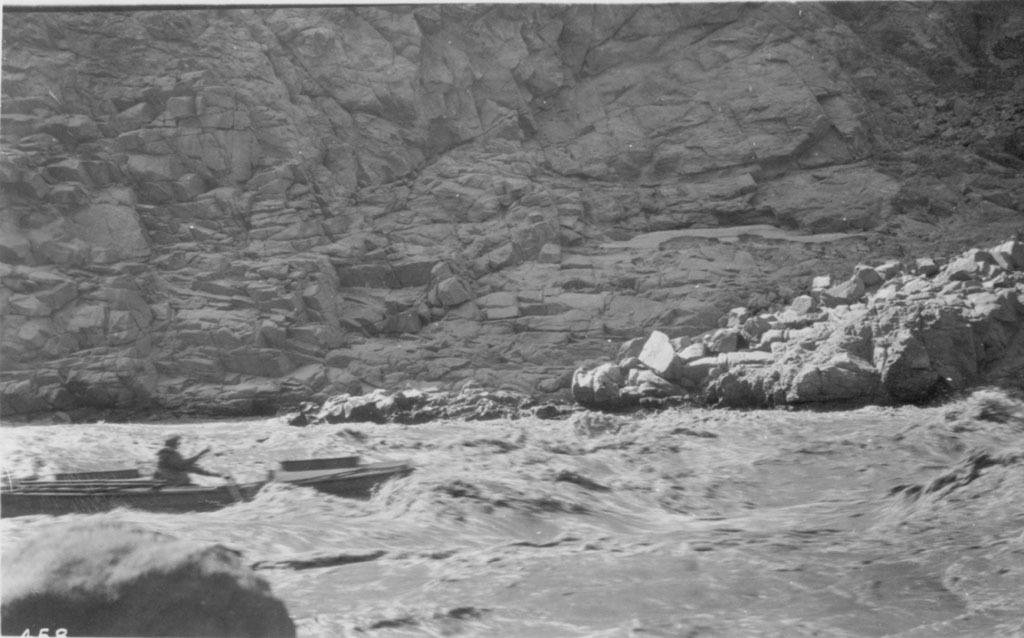What is the color scheme of the image? The image is black and white. What is the person in the image doing? The person is on a boat in the image. Where is the boat located? The boat is in the river. What can be seen in the background of the image? There is a mountain in the background of the image. What type of stem can be seen growing from the boat in the image? There is no stem growing from the boat in the image, as it is a black and white image of a person on a boat in a river with a mountain in the background. 